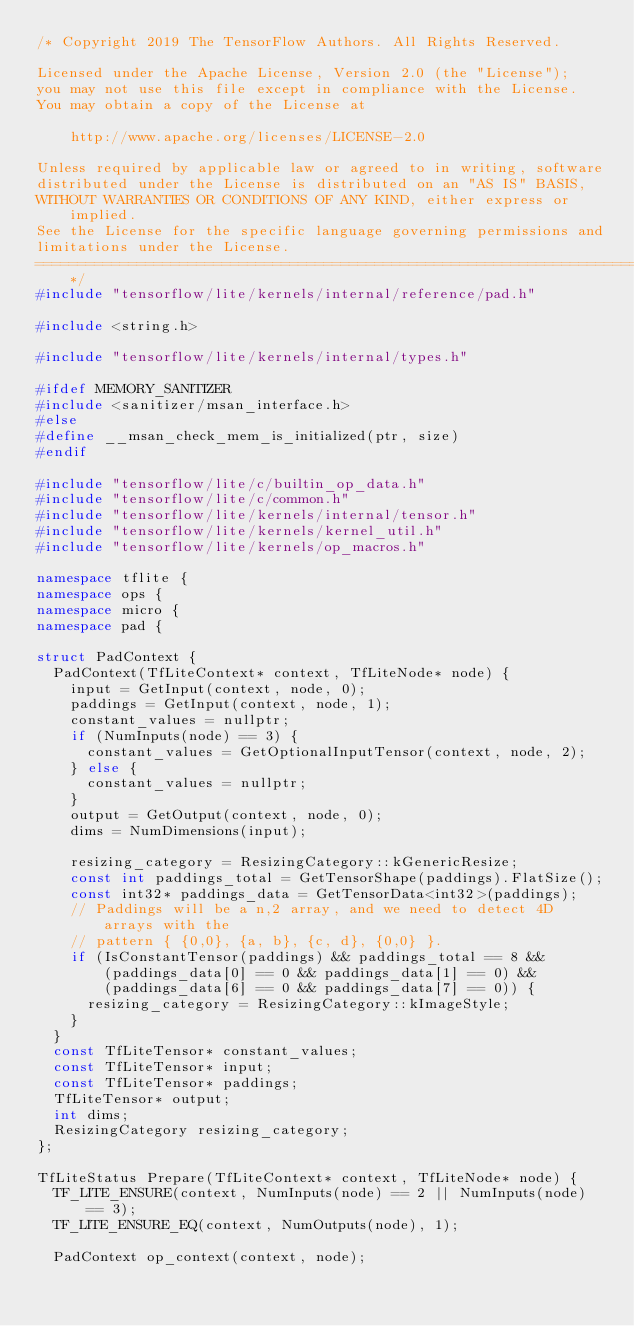Convert code to text. <code><loc_0><loc_0><loc_500><loc_500><_C++_>/* Copyright 2019 The TensorFlow Authors. All Rights Reserved.

Licensed under the Apache License, Version 2.0 (the "License");
you may not use this file except in compliance with the License.
You may obtain a copy of the License at

    http://www.apache.org/licenses/LICENSE-2.0

Unless required by applicable law or agreed to in writing, software
distributed under the License is distributed on an "AS IS" BASIS,
WITHOUT WARRANTIES OR CONDITIONS OF ANY KIND, either express or implied.
See the License for the specific language governing permissions and
limitations under the License.
==============================================================================*/
#include "tensorflow/lite/kernels/internal/reference/pad.h"

#include <string.h>

#include "tensorflow/lite/kernels/internal/types.h"

#ifdef MEMORY_SANITIZER
#include <sanitizer/msan_interface.h>
#else
#define __msan_check_mem_is_initialized(ptr, size)
#endif

#include "tensorflow/lite/c/builtin_op_data.h"
#include "tensorflow/lite/c/common.h"
#include "tensorflow/lite/kernels/internal/tensor.h"
#include "tensorflow/lite/kernels/kernel_util.h"
#include "tensorflow/lite/kernels/op_macros.h"

namespace tflite {
namespace ops {
namespace micro {
namespace pad {

struct PadContext {
  PadContext(TfLiteContext* context, TfLiteNode* node) {
    input = GetInput(context, node, 0);
    paddings = GetInput(context, node, 1);
    constant_values = nullptr;
    if (NumInputs(node) == 3) {
      constant_values = GetOptionalInputTensor(context, node, 2);
    } else {
      constant_values = nullptr;
    }
    output = GetOutput(context, node, 0);
    dims = NumDimensions(input);

    resizing_category = ResizingCategory::kGenericResize;
    const int paddings_total = GetTensorShape(paddings).FlatSize();
    const int32* paddings_data = GetTensorData<int32>(paddings);
    // Paddings will be a n,2 array, and we need to detect 4D arrays with the
    // pattern { {0,0}, {a, b}, {c, d}, {0,0} }.
    if (IsConstantTensor(paddings) && paddings_total == 8 &&
        (paddings_data[0] == 0 && paddings_data[1] == 0) &&
        (paddings_data[6] == 0 && paddings_data[7] == 0)) {
      resizing_category = ResizingCategory::kImageStyle;
    }
  }
  const TfLiteTensor* constant_values;
  const TfLiteTensor* input;
  const TfLiteTensor* paddings;
  TfLiteTensor* output;
  int dims;
  ResizingCategory resizing_category;
};

TfLiteStatus Prepare(TfLiteContext* context, TfLiteNode* node) {
  TF_LITE_ENSURE(context, NumInputs(node) == 2 || NumInputs(node) == 3);
  TF_LITE_ENSURE_EQ(context, NumOutputs(node), 1);

  PadContext op_context(context, node);</code> 